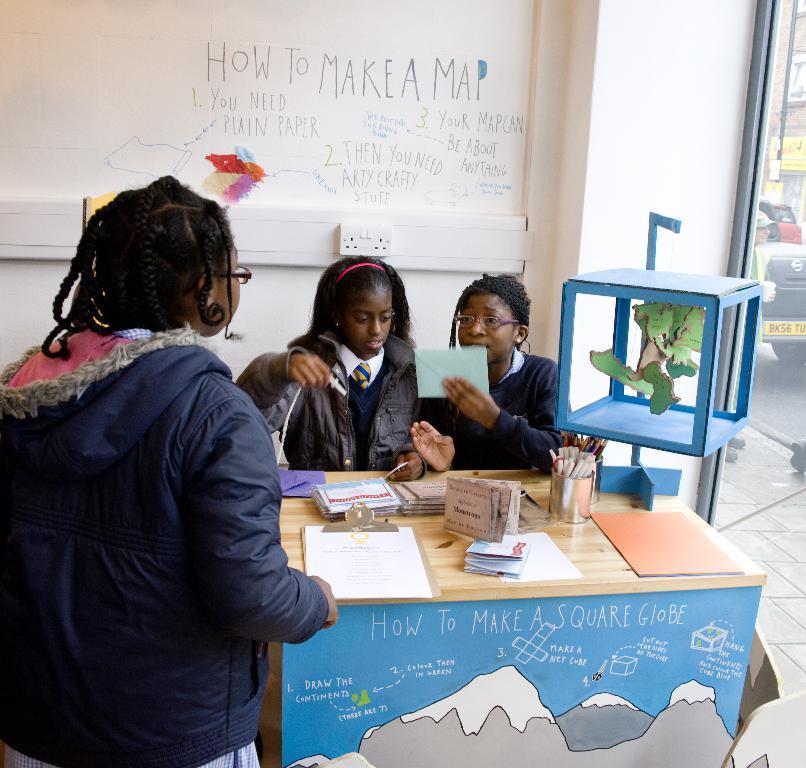In one or two sentences, can you explain what this image depicts? In this image i can see three persons two are sitting and one person is standing there are few papers, pens on a table at the back ground i can see a wall. 